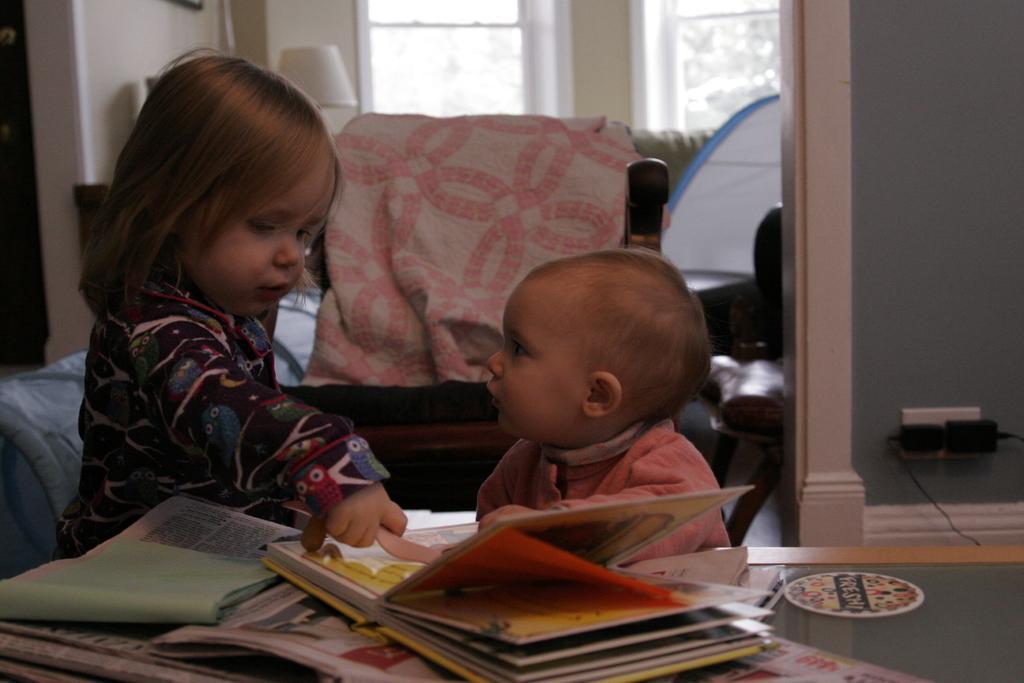Please provide a concise description of this image. In this image, I can see two kids standing. At the bottom of the image, there are books and newspapers on the table. In the background, I can see a couch, lamp, glass windows and few other objects. 